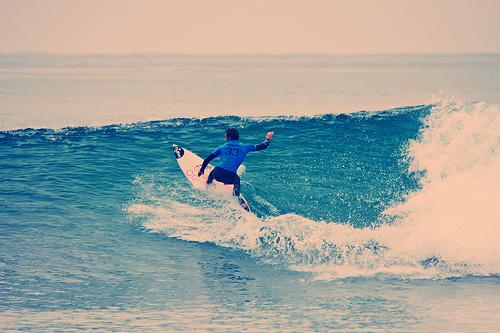Question: where was this picture taken?
Choices:
A. The ocean.
B. A river.
C. A mountain.
D. A house.
Answer with the letter. Answer: A Question: who is in the picture?
Choices:
A. A man.
B. A girl.
C. A baby.
D. An old man.
Answer with the letter. Answer: A Question: what number is on the man?
Choices:
A. 22.
B. 33.
C. 30.
D. 2.
Answer with the letter. Answer: B Question: what is the man doing?
Choices:
A. Running.
B. Swimming.
C. Sleeping.
D. Surfing.
Answer with the letter. Answer: D Question: what is the man standing on?
Choices:
A. Surfboard.
B. Docks.
C. Sand.
D. Sidewalk.
Answer with the letter. Answer: A 